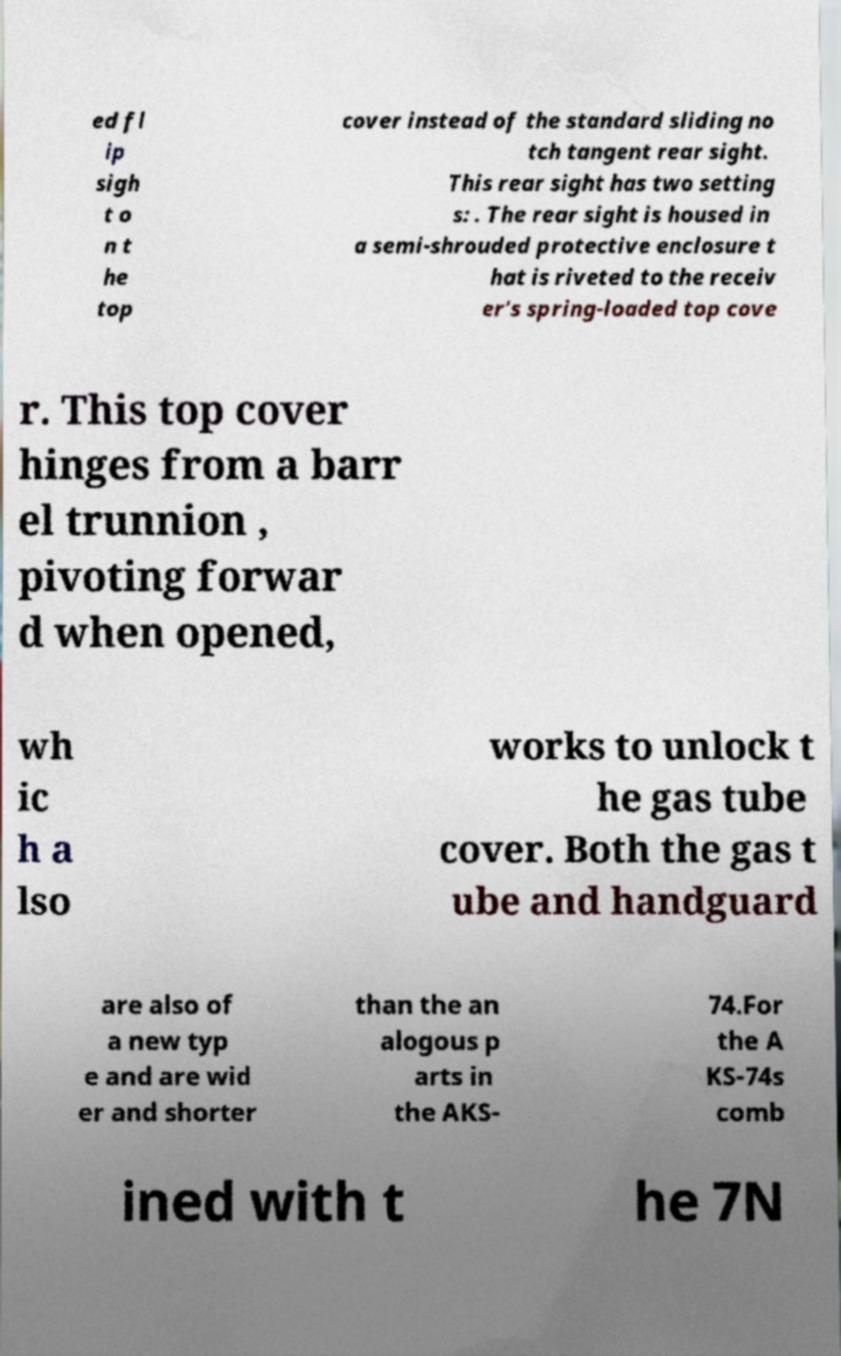Please identify and transcribe the text found in this image. ed fl ip sigh t o n t he top cover instead of the standard sliding no tch tangent rear sight. This rear sight has two setting s: . The rear sight is housed in a semi-shrouded protective enclosure t hat is riveted to the receiv er's spring-loaded top cove r. This top cover hinges from a barr el trunnion , pivoting forwar d when opened, wh ic h a lso works to unlock t he gas tube cover. Both the gas t ube and handguard are also of a new typ e and are wid er and shorter than the an alogous p arts in the AKS- 74.For the A KS-74s comb ined with t he 7N 